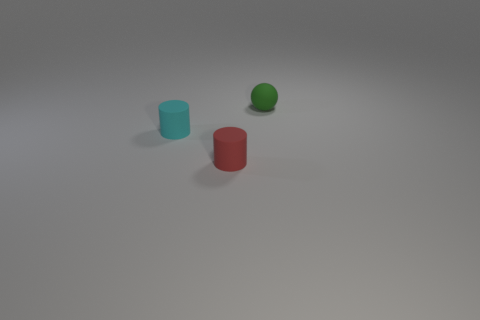Is the number of red rubber cylinders in front of the cyan cylinder greater than the number of tiny cyan rubber cylinders right of the small green sphere?
Your answer should be very brief. Yes. There is a small green thing that is the same material as the small cyan cylinder; what shape is it?
Your answer should be very brief. Sphere. Is there a small cylinder that is behind the tiny rubber object that is behind the tiny cyan thing?
Provide a succinct answer. No. What size is the cyan cylinder?
Keep it short and to the point. Small. What number of things are either purple cubes or tiny red things?
Offer a terse response. 1. Are the thing that is right of the small red cylinder and the small cylinder that is right of the cyan matte object made of the same material?
Offer a very short reply. Yes. What color is the small sphere that is the same material as the red cylinder?
Your response must be concise. Green. How many other cyan spheres have the same size as the rubber sphere?
Make the answer very short. 0. Is there anything else that is the same size as the green rubber sphere?
Your answer should be very brief. Yes. Is the shape of the rubber thing that is on the right side of the tiny red thing the same as the thing in front of the small cyan matte thing?
Make the answer very short. No. 